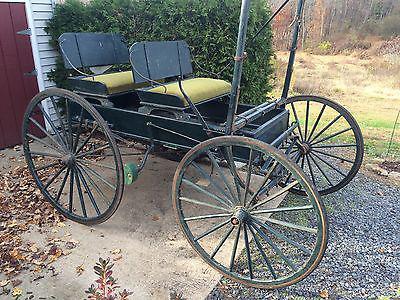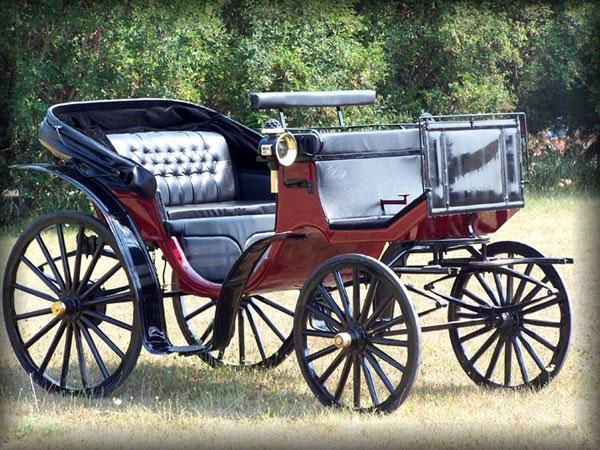The first image is the image on the left, the second image is the image on the right. For the images displayed, is the sentence "At least one buggy has no cover on the passenger area." factually correct? Answer yes or no. Yes. 